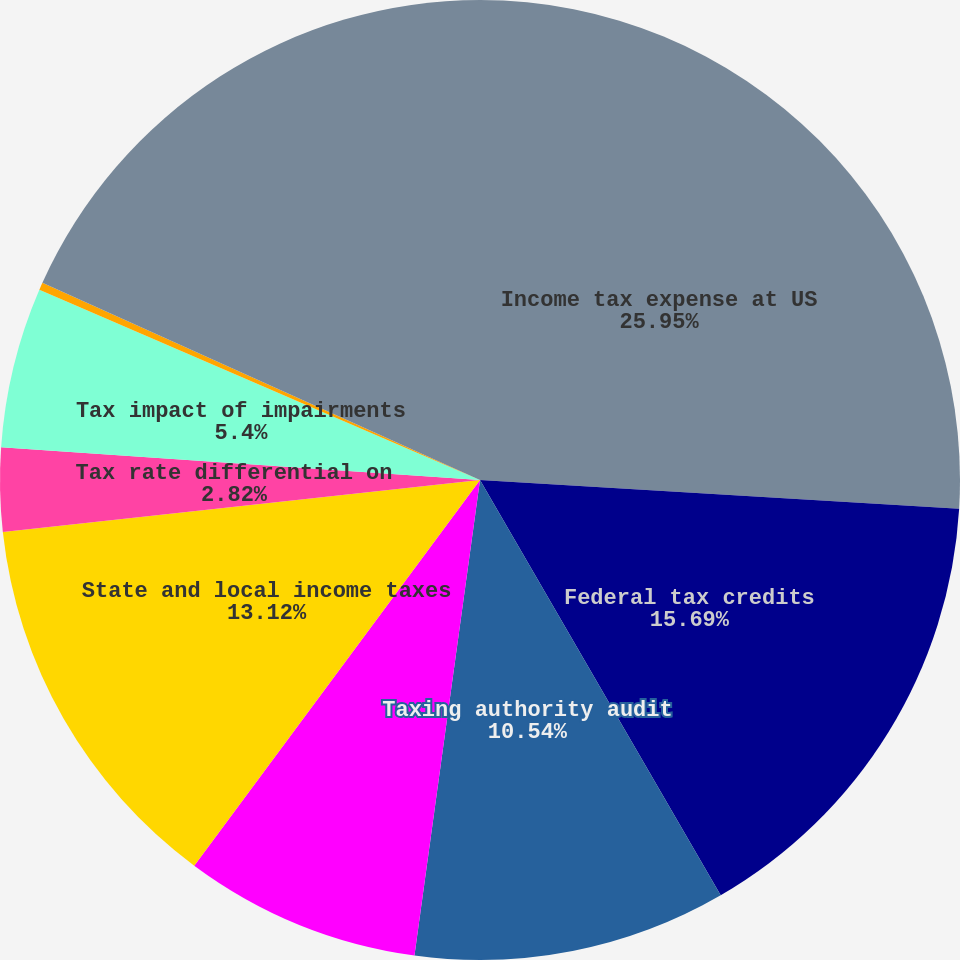Convert chart. <chart><loc_0><loc_0><loc_500><loc_500><pie_chart><fcel>Income tax expense at US<fcel>Federal tax credits<fcel>Taxing authority audit<fcel>Noncontrolling interests<fcel>State and local income taxes<fcel>Tax rate differential on<fcel>Tax impact of impairments<fcel>Other<fcel>Provision for income taxes<nl><fcel>25.95%<fcel>15.69%<fcel>10.54%<fcel>7.97%<fcel>13.12%<fcel>2.82%<fcel>5.4%<fcel>0.25%<fcel>18.26%<nl></chart> 